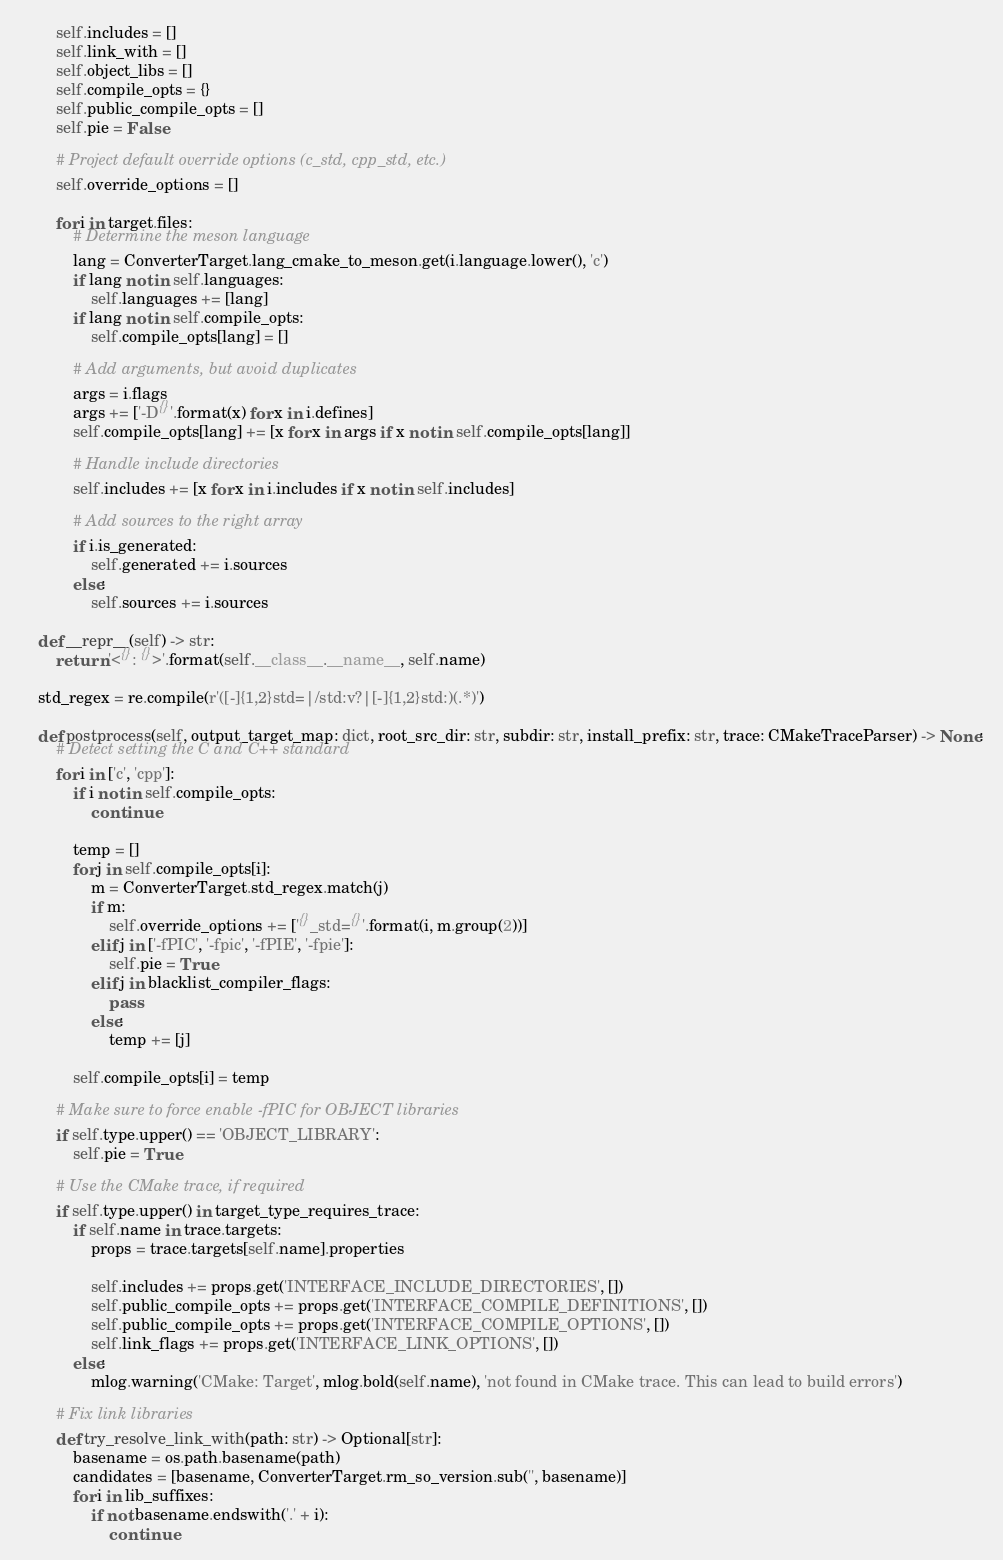<code> <loc_0><loc_0><loc_500><loc_500><_Python_>        self.includes = []
        self.link_with = []
        self.object_libs = []
        self.compile_opts = {}
        self.public_compile_opts = []
        self.pie = False

        # Project default override options (c_std, cpp_std, etc.)
        self.override_options = []

        for i in target.files:
            # Determine the meson language
            lang = ConverterTarget.lang_cmake_to_meson.get(i.language.lower(), 'c')
            if lang not in self.languages:
                self.languages += [lang]
            if lang not in self.compile_opts:
                self.compile_opts[lang] = []

            # Add arguments, but avoid duplicates
            args = i.flags
            args += ['-D{}'.format(x) for x in i.defines]
            self.compile_opts[lang] += [x for x in args if x not in self.compile_opts[lang]]

            # Handle include directories
            self.includes += [x for x in i.includes if x not in self.includes]

            # Add sources to the right array
            if i.is_generated:
                self.generated += i.sources
            else:
                self.sources += i.sources

    def __repr__(self) -> str:
        return '<{}: {}>'.format(self.__class__.__name__, self.name)

    std_regex = re.compile(r'([-]{1,2}std=|/std:v?|[-]{1,2}std:)(.*)')

    def postprocess(self, output_target_map: dict, root_src_dir: str, subdir: str, install_prefix: str, trace: CMakeTraceParser) -> None:
        # Detect setting the C and C++ standard
        for i in ['c', 'cpp']:
            if i not in self.compile_opts:
                continue

            temp = []
            for j in self.compile_opts[i]:
                m = ConverterTarget.std_regex.match(j)
                if m:
                    self.override_options += ['{}_std={}'.format(i, m.group(2))]
                elif j in ['-fPIC', '-fpic', '-fPIE', '-fpie']:
                    self.pie = True
                elif j in blacklist_compiler_flags:
                    pass
                else:
                    temp += [j]

            self.compile_opts[i] = temp

        # Make sure to force enable -fPIC for OBJECT libraries
        if self.type.upper() == 'OBJECT_LIBRARY':
            self.pie = True

        # Use the CMake trace, if required
        if self.type.upper() in target_type_requires_trace:
            if self.name in trace.targets:
                props = trace.targets[self.name].properties

                self.includes += props.get('INTERFACE_INCLUDE_DIRECTORIES', [])
                self.public_compile_opts += props.get('INTERFACE_COMPILE_DEFINITIONS', [])
                self.public_compile_opts += props.get('INTERFACE_COMPILE_OPTIONS', [])
                self.link_flags += props.get('INTERFACE_LINK_OPTIONS', [])
            else:
                mlog.warning('CMake: Target', mlog.bold(self.name), 'not found in CMake trace. This can lead to build errors')

        # Fix link libraries
        def try_resolve_link_with(path: str) -> Optional[str]:
            basename = os.path.basename(path)
            candidates = [basename, ConverterTarget.rm_so_version.sub('', basename)]
            for i in lib_suffixes:
                if not basename.endswith('.' + i):
                    continue</code> 